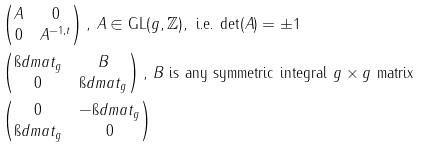Convert formula to latex. <formula><loc_0><loc_0><loc_500><loc_500>& \begin{pmatrix} A & 0 \\ 0 & A ^ { - 1 , t } \end{pmatrix} , \, A \in \text {GL} ( g , \mathbb { Z } ) , \text { i.e. det} ( A ) = \pm 1 \\ & \begin{pmatrix} \i d m a t _ { g } & B \\ 0 & \i d m a t _ { g } \end{pmatrix} , \, B \text { is any symmetric integral } g \times g \text { matrix} \\ & \begin{pmatrix} 0 & - \i d m a t _ { g } \\ \i d m a t _ { g } & 0 \end{pmatrix}</formula> 